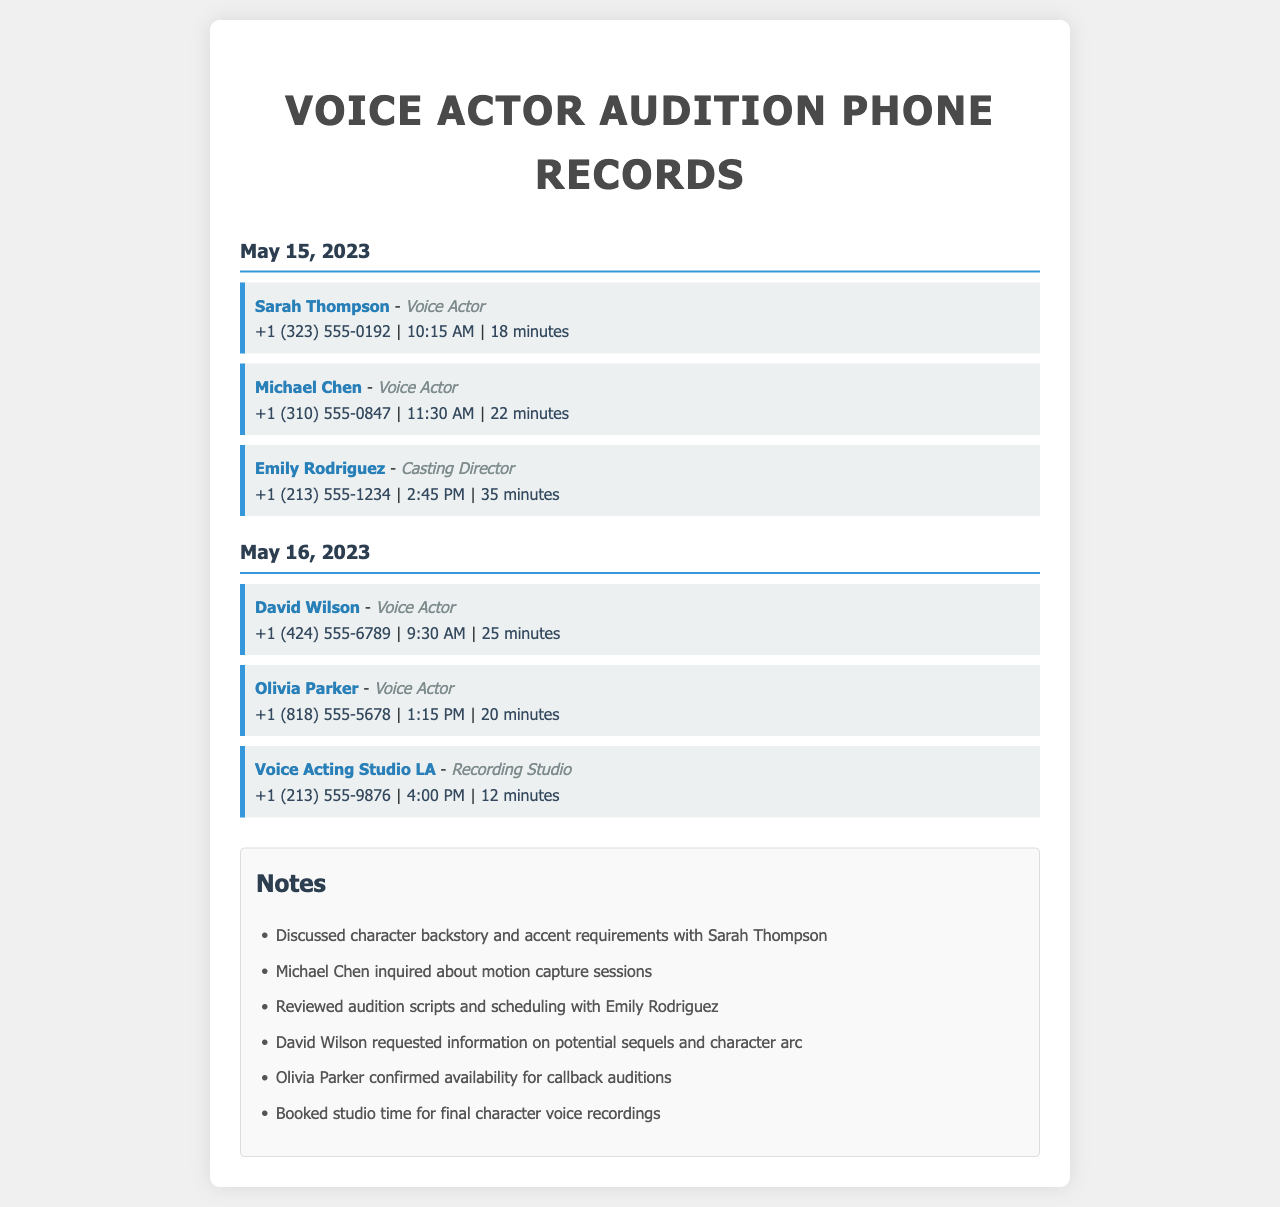What is the date of the first phone records? The first set of phone records is dated May 15, 2023.
Answer: May 15, 2023 Who was the contact for the second call on May 15, 2023? The second call on May 15, 2023 was with Michael Chen.
Answer: Michael Chen What was the duration of the call with David Wilson? The duration of the call with David Wilson was 25 minutes.
Answer: 25 minutes What role does Emily Rodriguez have? Emily Rodriguez is a Casting Director according to the document.
Answer: Casting Director How many minutes did Sarah Thompson's call last? Sarah Thompson's call lasted for 18 minutes.
Answer: 18 minutes Which voice actor in the records discussed character backstory? Sarah Thompson discussed character backstory during her call.
Answer: Sarah Thompson What time did Olivia Parker's call occur? Olivia Parker's call occurred at 1:15 PM.
Answer: 1:15 PM What topic did Michael Chen inquire about? Michael Chen inquired about motion capture sessions during his call.
Answer: Motion capture sessions What type of establishment is Voice Acting Studio LA? Voice Acting Studio LA is identified as a Recording Studio in the records.
Answer: Recording Studio 